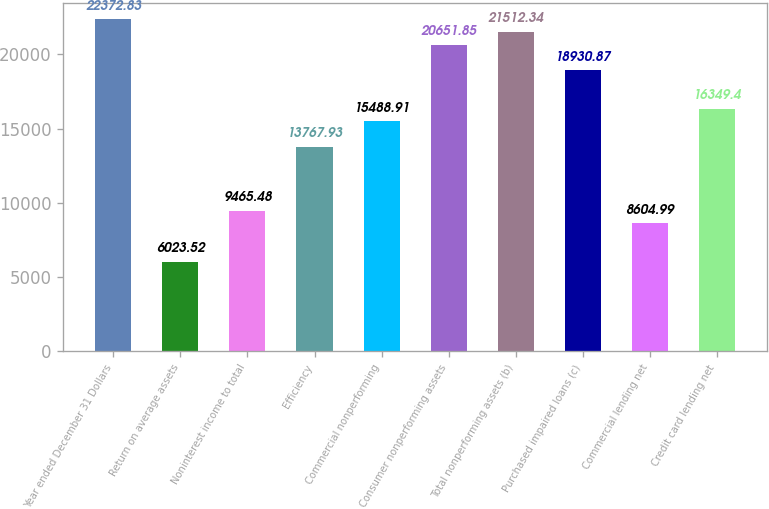<chart> <loc_0><loc_0><loc_500><loc_500><bar_chart><fcel>Year ended December 31 Dollars<fcel>Return on average assets<fcel>Noninterest income to total<fcel>Efficiency<fcel>Commercial nonperforming<fcel>Consumer nonperforming assets<fcel>Total nonperforming assets (b)<fcel>Purchased impaired loans (c)<fcel>Commercial lending net<fcel>Credit card lending net<nl><fcel>22372.8<fcel>6023.52<fcel>9465.48<fcel>13767.9<fcel>15488.9<fcel>20651.8<fcel>21512.3<fcel>18930.9<fcel>8604.99<fcel>16349.4<nl></chart> 